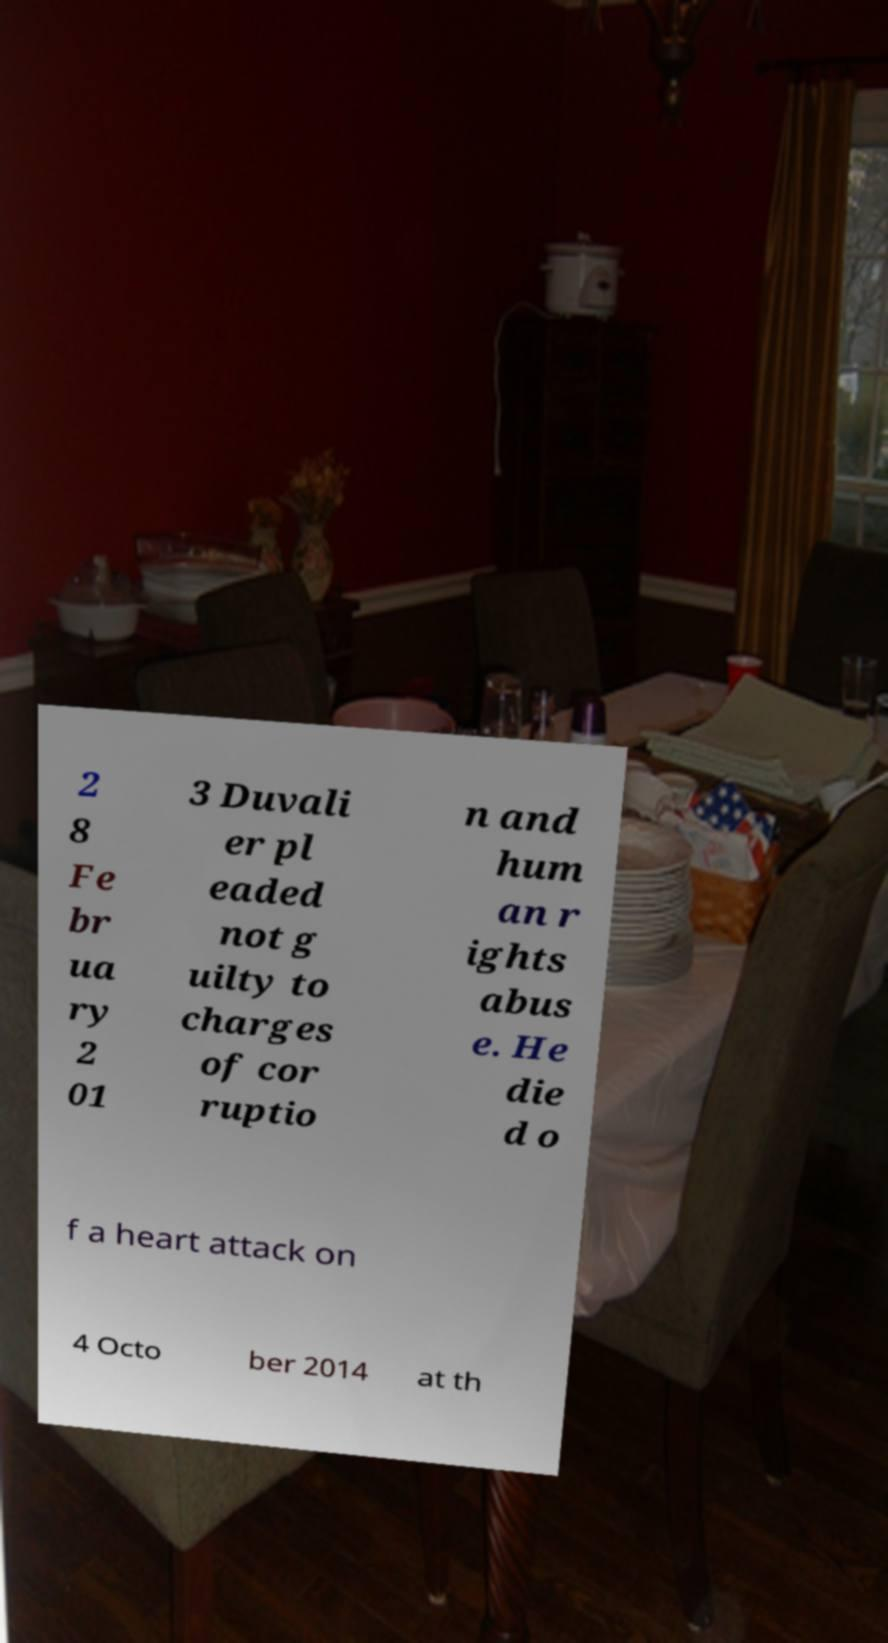Could you assist in decoding the text presented in this image and type it out clearly? 2 8 Fe br ua ry 2 01 3 Duvali er pl eaded not g uilty to charges of cor ruptio n and hum an r ights abus e. He die d o f a heart attack on 4 Octo ber 2014 at th 